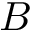<formula> <loc_0><loc_0><loc_500><loc_500>B</formula> 